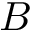<formula> <loc_0><loc_0><loc_500><loc_500>B</formula> 